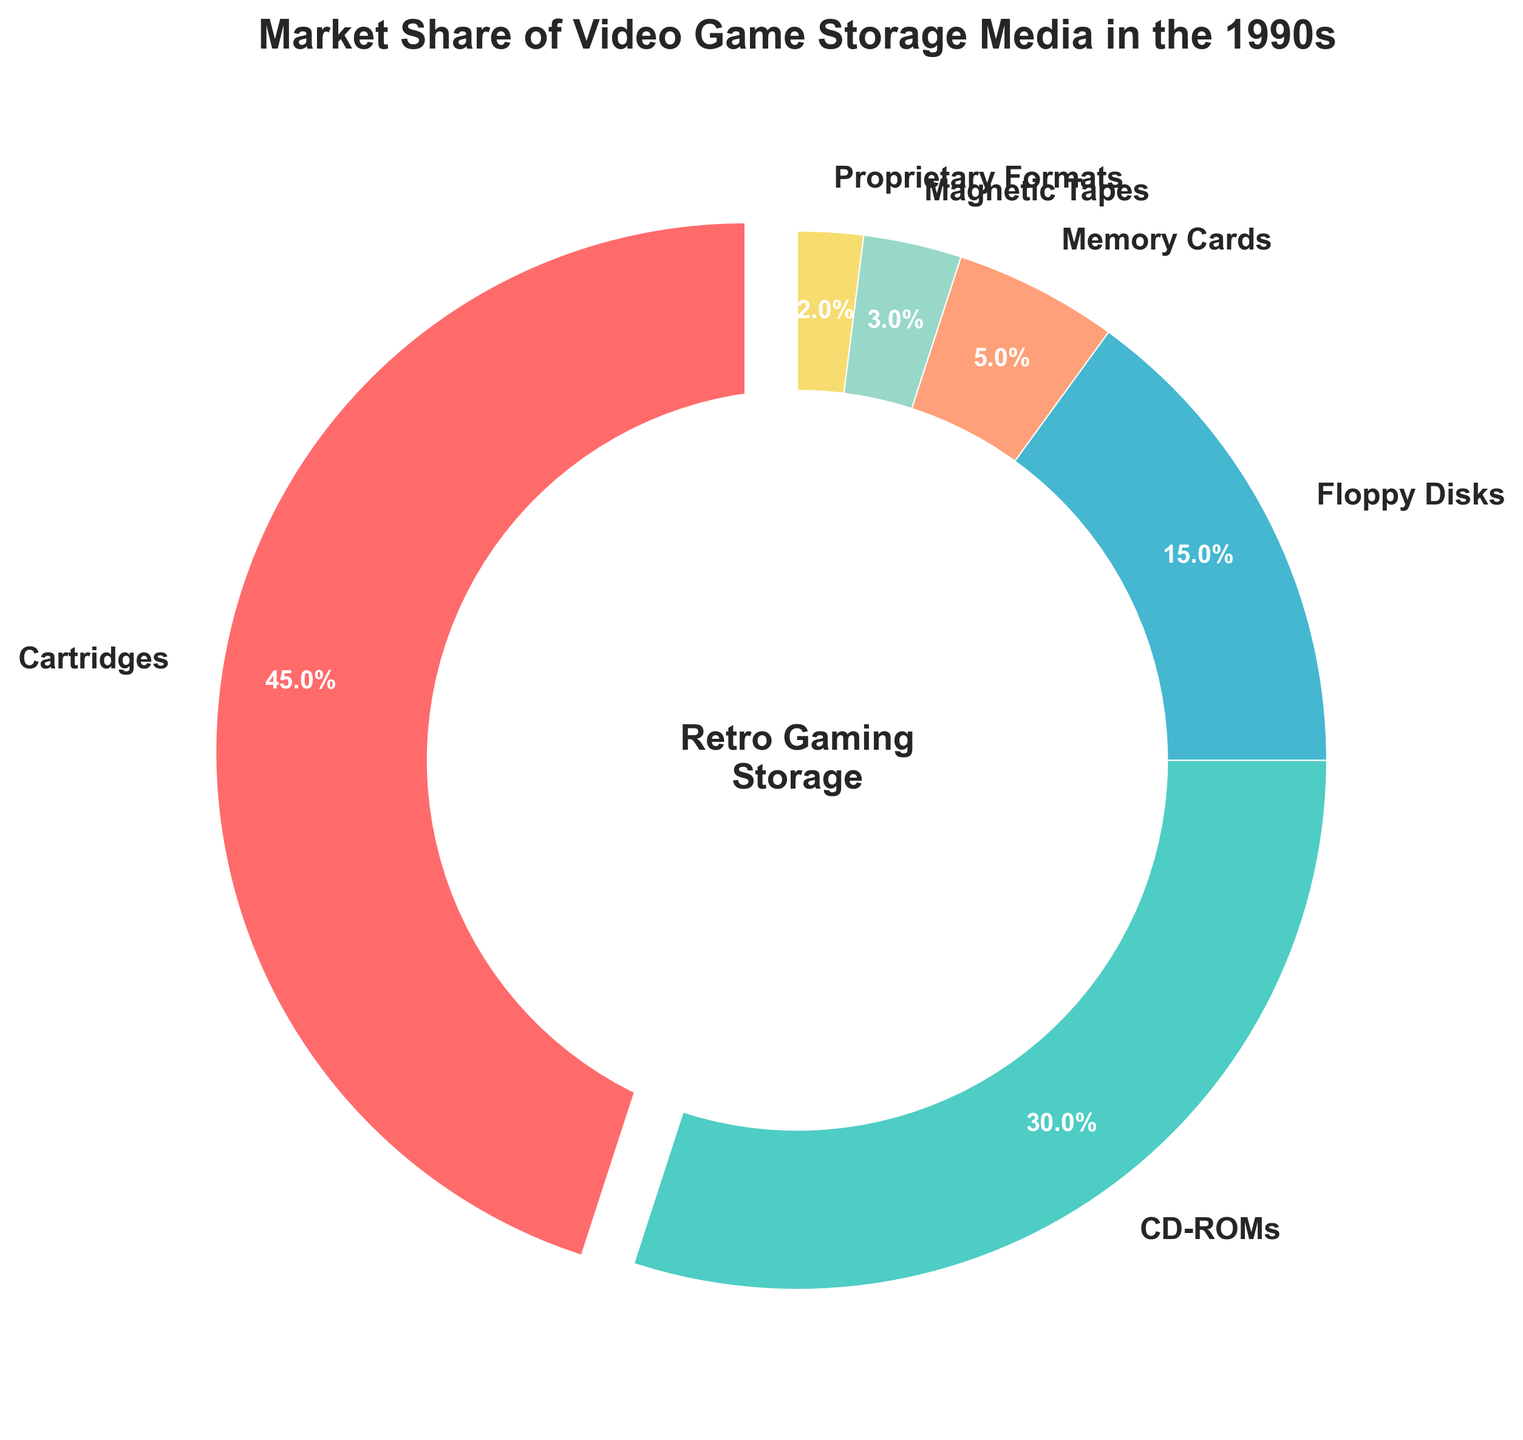What percentage of the market share was held by Cartridges and CD-ROMs combined? To get the combined market share of Cartridges and CD-ROMs, add their individual market shares: 45% (Cartridges) + 30% (CD-ROMs) = 75%.
Answer: 75% Which storage medium had the lowest market share in the 1990s? To determine which storage medium had the lowest market share, look at the given percentages. Proprietary Formats have the smallest share with 2%.
Answer: Proprietary Formats Between Floppy Disks and Memory Cards, which had a higher market share and by how much? Floppy Disks had a market share of 15%, while Memory Cards had a share of 5%. The difference is 15% - 5% = 10%.
Answer: Floppy Disks by 10% What is the average market share of the storage media that are not Cartridges? First, sum the market shares of the non-Cartridge media: 30% (CD-ROMs) + 15% (Floppy Disks) + 5% (Memory Cards) + 3% (Magnetic Tapes) + 2% (Proprietary Formats) = 55%. There are 5 non-Cartridge media, so the average is 55% / 5 = 11%.
Answer: 11% Which storage medium had a market share more than three times that of Magnetic Tapes? Magnetic Tapes had a market share of 3%. Three times that is 3% * 3 = 9%. Both Cartridges (45%) and CD-ROMs (30%) have more than three times the market share of Magnetic Tapes.
Answer: Cartridges, CD-ROMs Identify the storage medium that represented less than 5% of the market share and describe its color. Magnetic Tapes (3%) and Proprietary Formats (2%) each represented less than 5% of the market; their colors in the plot are respectively likely greenish and yellowish. For better clarity without the figure, it's important we note the colors are consistent with general visual trends for lowest slices.
Answer: Magnetic Tapes (likely greenish) and Proprietary Formats (likely yellowish) How much greater is the market share of Cartridges compared to that of Floppy Disks and Memory Cards combined? First, combine the market shares of Floppy Disks and Memory Cards: 15% + 5% = 20%. Then, subtract this from the market share of Cartridges: 45% - 20% = 25%.
Answer: 25% What percentage of the market does the second largest storage medium comprise? The second largest storage medium is CD-ROMs with a market share of 30%.
Answer: 30% If we consider only Cartridges and CD-ROMs, what fraction do CD-ROMs represent? Cartridges have a 45% market share, and CD-ROMs have 30%. The total for these two is 45% + 30% = 75%. CD-ROMs' fraction is 30% / 75% = 2/5.
Answer: 2/5 If the pie chart's title were to be more descriptive, how might it be phrased? The title should encompass both the time period and the concept, such as: "Market Share Distribution of Video Game Storage Media in the 1990s."
Answer: Market Share Distribution of Video Game Storage Media in the 1990s 